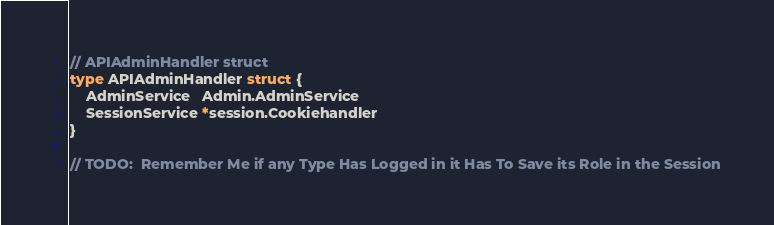<code> <loc_0><loc_0><loc_500><loc_500><_Go_>// APIAdminHandler struct
type APIAdminHandler struct {
	AdminService   Admin.AdminService
	SessionService *session.Cookiehandler
}

// TODO:  Remember Me if any Type Has Logged in it Has To Save its Role in the Session
</code> 